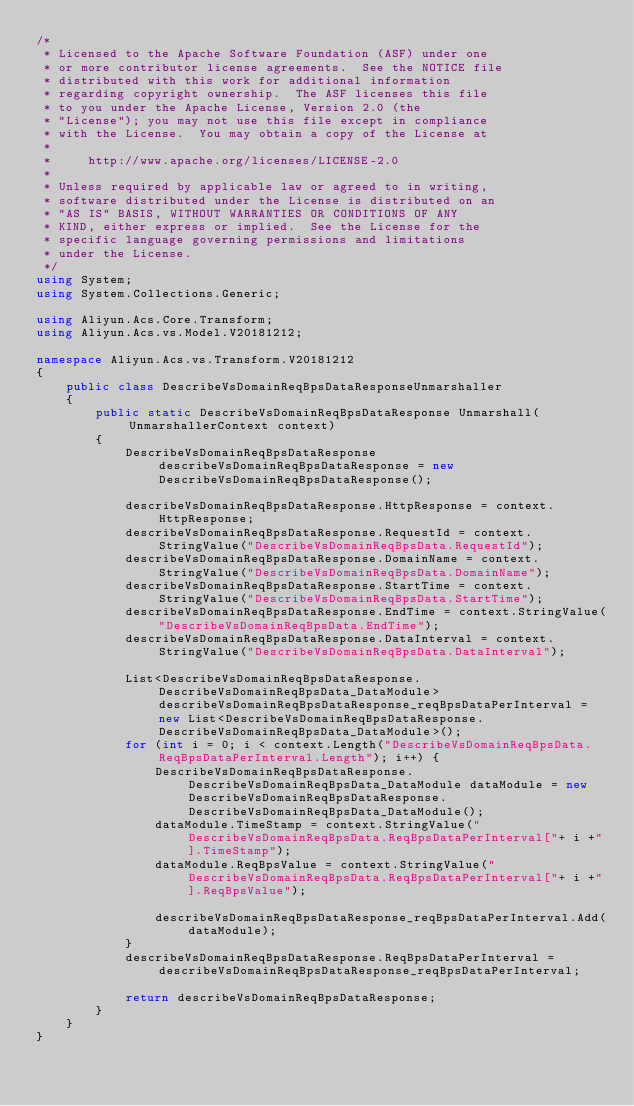Convert code to text. <code><loc_0><loc_0><loc_500><loc_500><_C#_>/*
 * Licensed to the Apache Software Foundation (ASF) under one
 * or more contributor license agreements.  See the NOTICE file
 * distributed with this work for additional information
 * regarding copyright ownership.  The ASF licenses this file
 * to you under the Apache License, Version 2.0 (the
 * "License"); you may not use this file except in compliance
 * with the License.  You may obtain a copy of the License at
 *
 *     http://www.apache.org/licenses/LICENSE-2.0
 *
 * Unless required by applicable law or agreed to in writing,
 * software distributed under the License is distributed on an
 * "AS IS" BASIS, WITHOUT WARRANTIES OR CONDITIONS OF ANY
 * KIND, either express or implied.  See the License for the
 * specific language governing permissions and limitations
 * under the License.
 */
using System;
using System.Collections.Generic;

using Aliyun.Acs.Core.Transform;
using Aliyun.Acs.vs.Model.V20181212;

namespace Aliyun.Acs.vs.Transform.V20181212
{
    public class DescribeVsDomainReqBpsDataResponseUnmarshaller
    {
        public static DescribeVsDomainReqBpsDataResponse Unmarshall(UnmarshallerContext context)
        {
			DescribeVsDomainReqBpsDataResponse describeVsDomainReqBpsDataResponse = new DescribeVsDomainReqBpsDataResponse();

			describeVsDomainReqBpsDataResponse.HttpResponse = context.HttpResponse;
			describeVsDomainReqBpsDataResponse.RequestId = context.StringValue("DescribeVsDomainReqBpsData.RequestId");
			describeVsDomainReqBpsDataResponse.DomainName = context.StringValue("DescribeVsDomainReqBpsData.DomainName");
			describeVsDomainReqBpsDataResponse.StartTime = context.StringValue("DescribeVsDomainReqBpsData.StartTime");
			describeVsDomainReqBpsDataResponse.EndTime = context.StringValue("DescribeVsDomainReqBpsData.EndTime");
			describeVsDomainReqBpsDataResponse.DataInterval = context.StringValue("DescribeVsDomainReqBpsData.DataInterval");

			List<DescribeVsDomainReqBpsDataResponse.DescribeVsDomainReqBpsData_DataModule> describeVsDomainReqBpsDataResponse_reqBpsDataPerInterval = new List<DescribeVsDomainReqBpsDataResponse.DescribeVsDomainReqBpsData_DataModule>();
			for (int i = 0; i < context.Length("DescribeVsDomainReqBpsData.ReqBpsDataPerInterval.Length"); i++) {
				DescribeVsDomainReqBpsDataResponse.DescribeVsDomainReqBpsData_DataModule dataModule = new DescribeVsDomainReqBpsDataResponse.DescribeVsDomainReqBpsData_DataModule();
				dataModule.TimeStamp = context.StringValue("DescribeVsDomainReqBpsData.ReqBpsDataPerInterval["+ i +"].TimeStamp");
				dataModule.ReqBpsValue = context.StringValue("DescribeVsDomainReqBpsData.ReqBpsDataPerInterval["+ i +"].ReqBpsValue");

				describeVsDomainReqBpsDataResponse_reqBpsDataPerInterval.Add(dataModule);
			}
			describeVsDomainReqBpsDataResponse.ReqBpsDataPerInterval = describeVsDomainReqBpsDataResponse_reqBpsDataPerInterval;
        
			return describeVsDomainReqBpsDataResponse;
        }
    }
}
</code> 